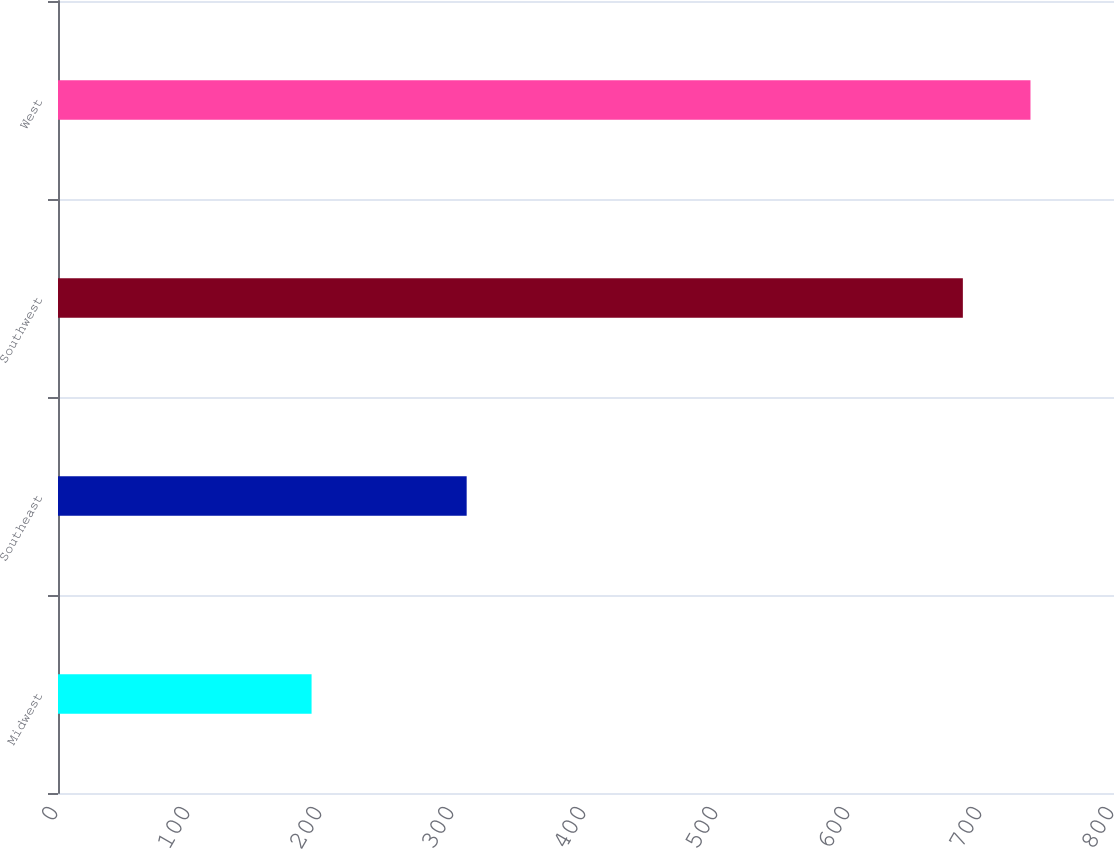<chart> <loc_0><loc_0><loc_500><loc_500><bar_chart><fcel>Midwest<fcel>Southeast<fcel>Southwest<fcel>West<nl><fcel>192.1<fcel>309.6<fcel>685.5<fcel>736.73<nl></chart> 